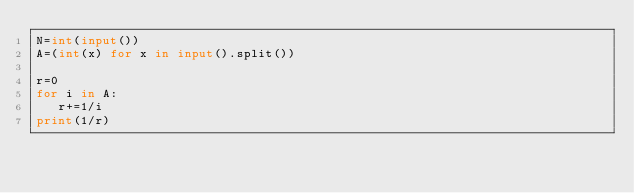Convert code to text. <code><loc_0><loc_0><loc_500><loc_500><_Python_>N=int(input())
A=(int(x) for x in input().split())

r=0
for i in A:
   r+=1/i
print(1/r)
</code> 